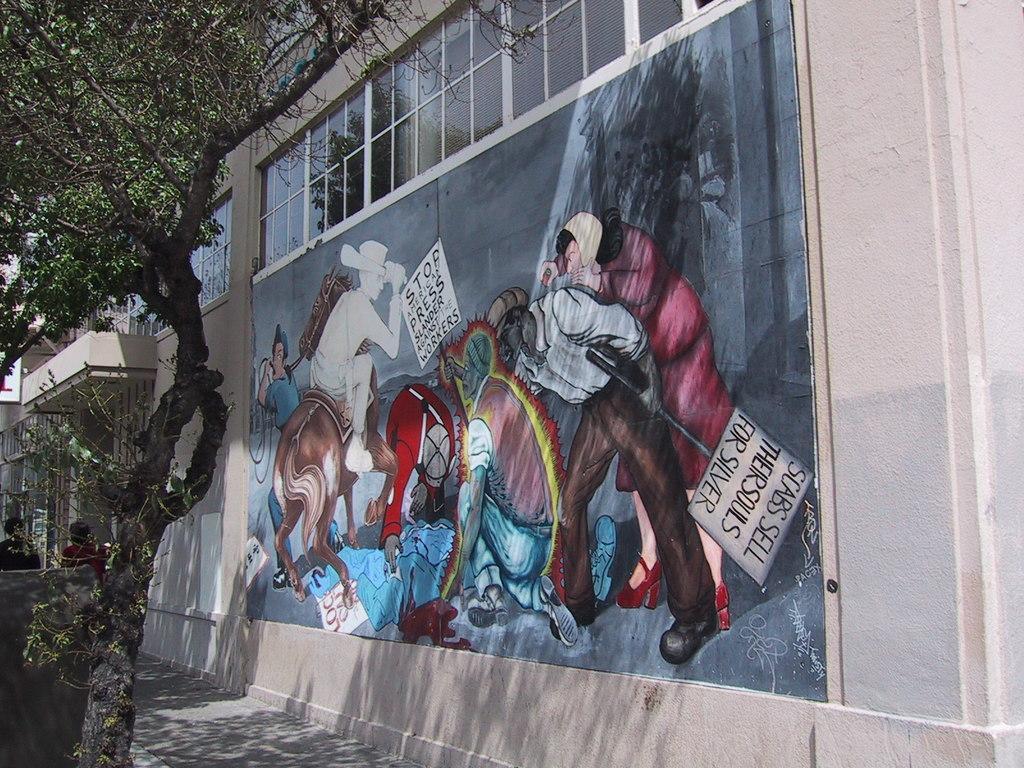Please provide a concise description of this image. There is a tree and painting on the wall in the foreground area of the image. 